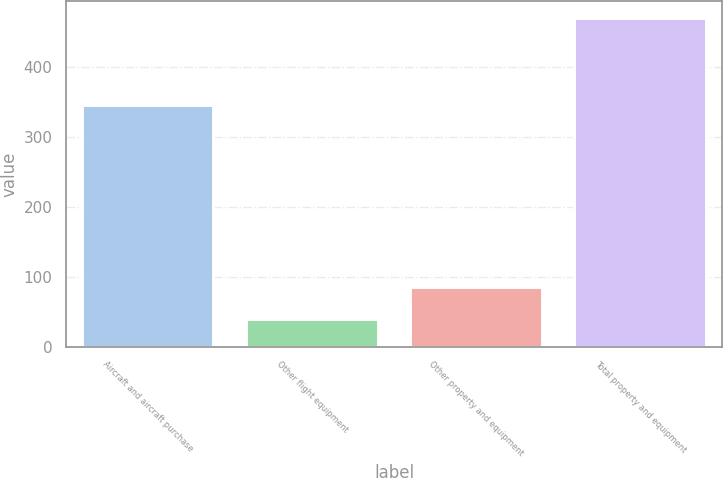Convert chart to OTSL. <chart><loc_0><loc_0><loc_500><loc_500><bar_chart><fcel>Aircraft and aircraft purchase<fcel>Other flight equipment<fcel>Other property and equipment<fcel>Total property and equipment<nl><fcel>345<fcel>40<fcel>85<fcel>470<nl></chart> 